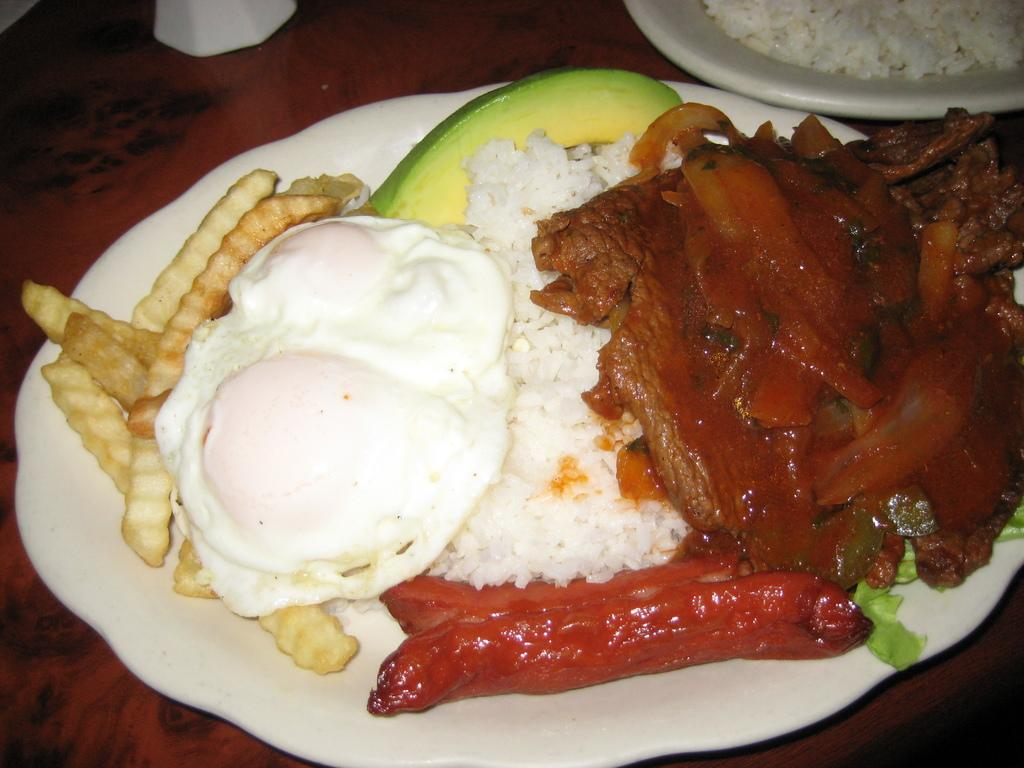What is present on the plates in the image? There is food in the plates. Can you describe the object on the platform? Unfortunately, the provided facts do not give enough information to describe the object on the platform. What language is spoken by the toes in the image? There are no toes present in the image, so this question cannot be answered. 